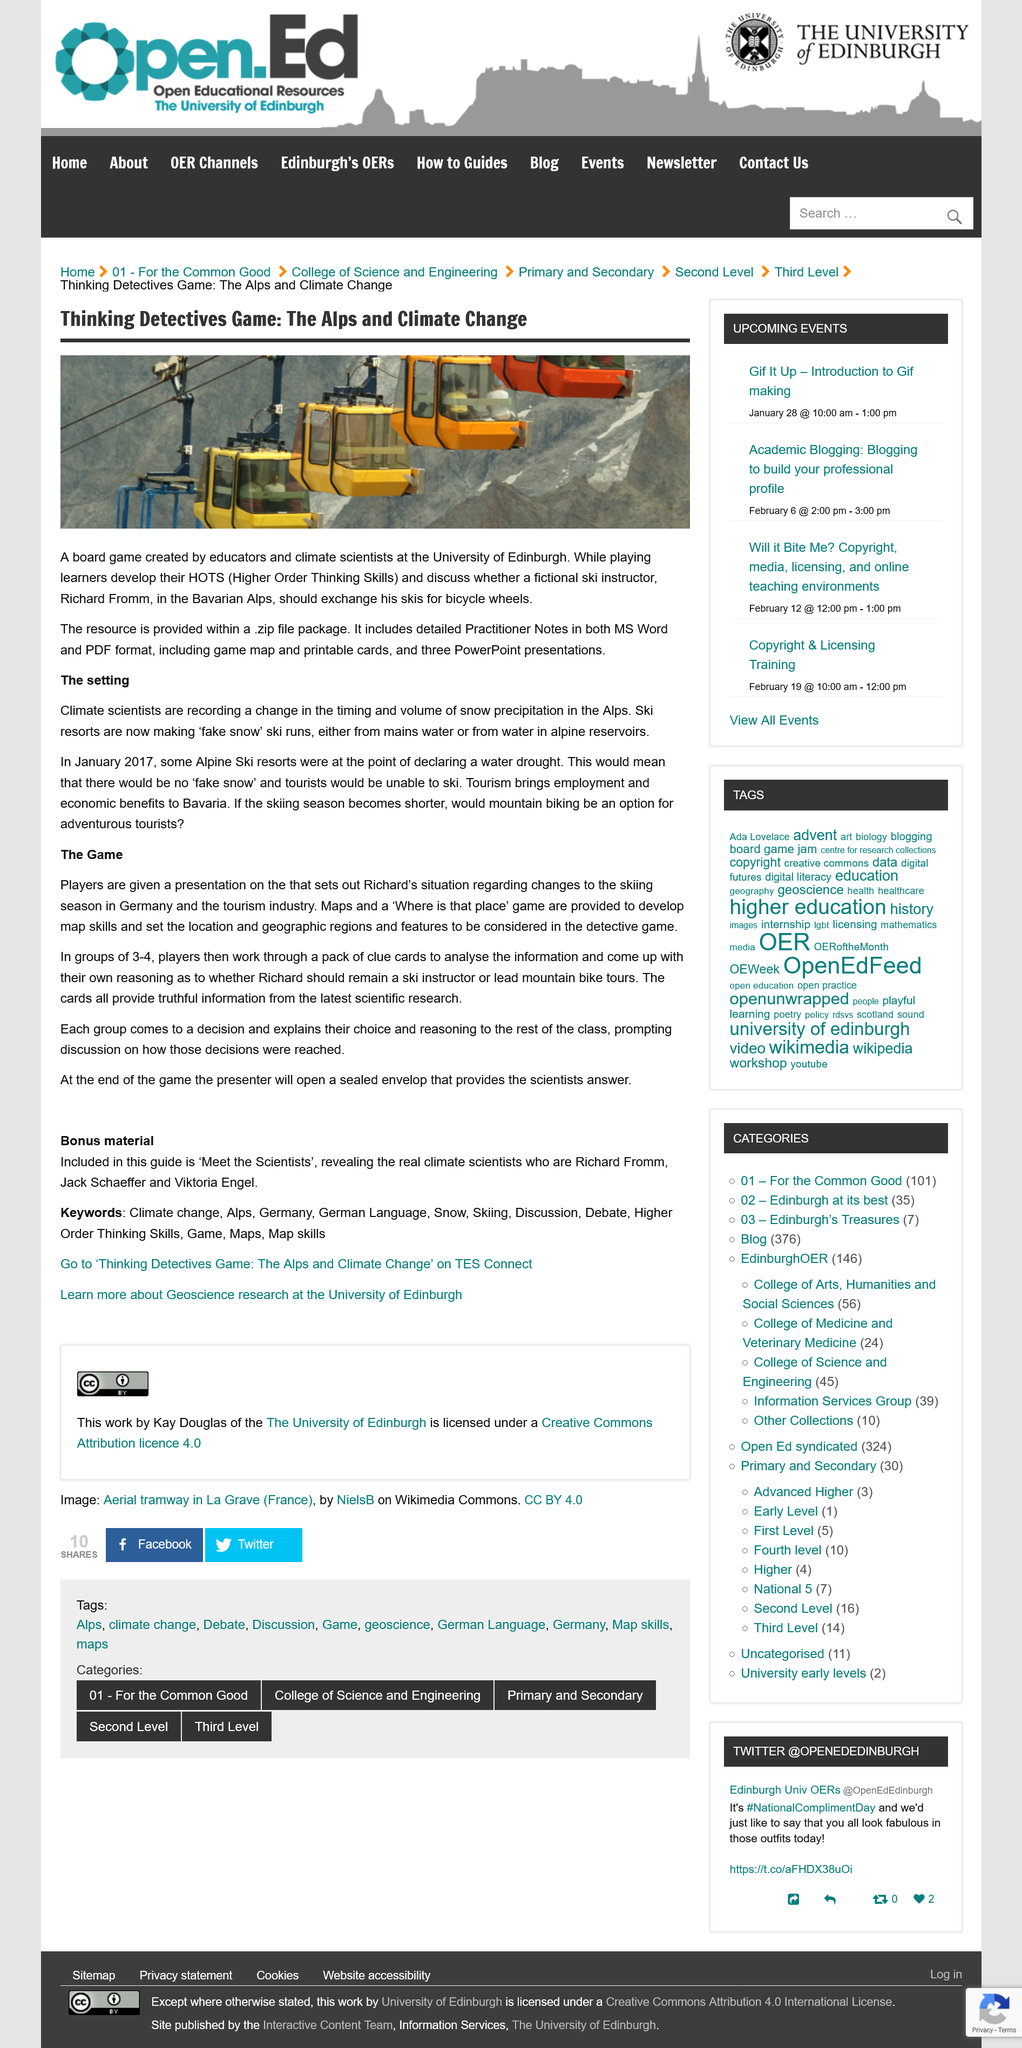Point out several critical features in this image. Some ski resorts were at the point of declaring a water drought in January 2017. Skiing is one of the keywords. This article discusses a board game that focuses on the Alps and Climate Change, providing insight into the impact of climate change on the region. The recording of the change in the timing and volume of snow precipitation is being conducted by climate scientists. 